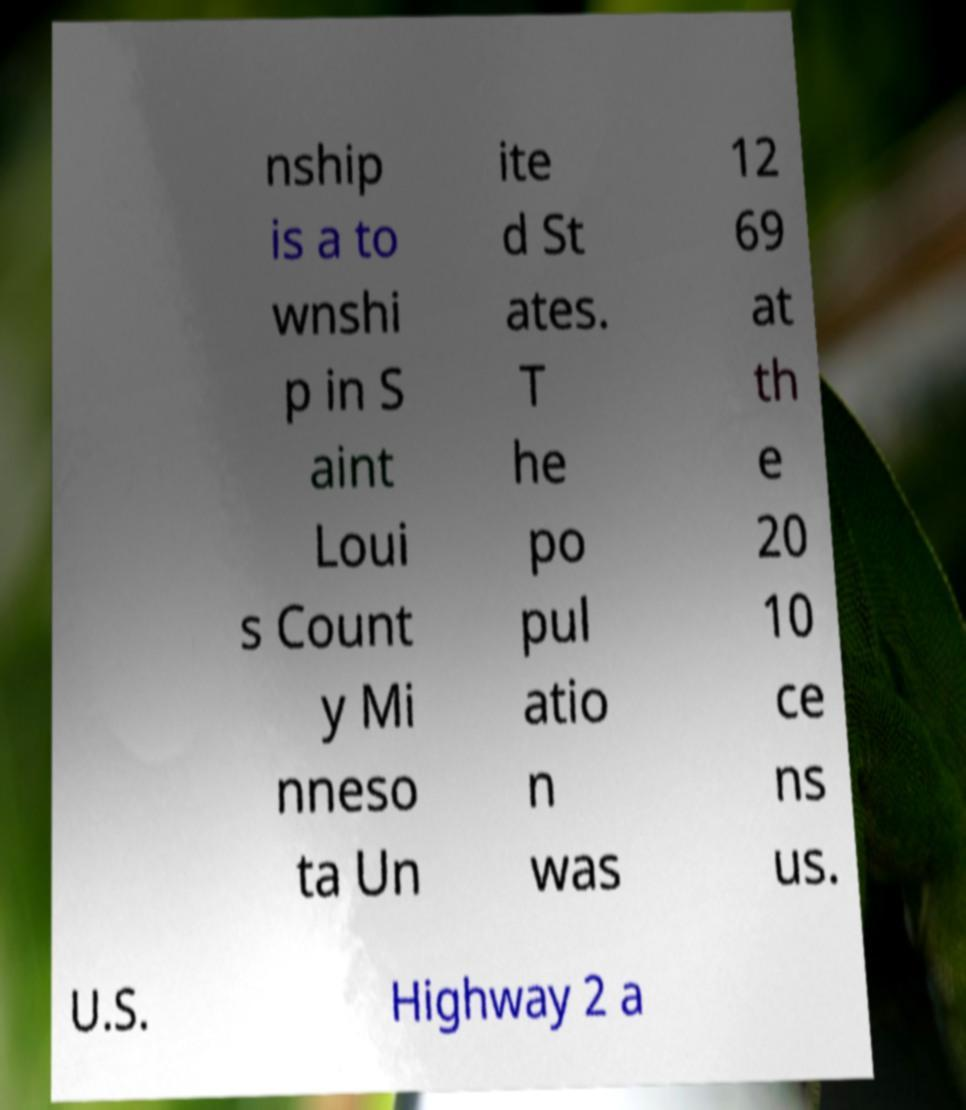Please read and relay the text visible in this image. What does it say? nship is a to wnshi p in S aint Loui s Count y Mi nneso ta Un ite d St ates. T he po pul atio n was 12 69 at th e 20 10 ce ns us. U.S. Highway 2 a 